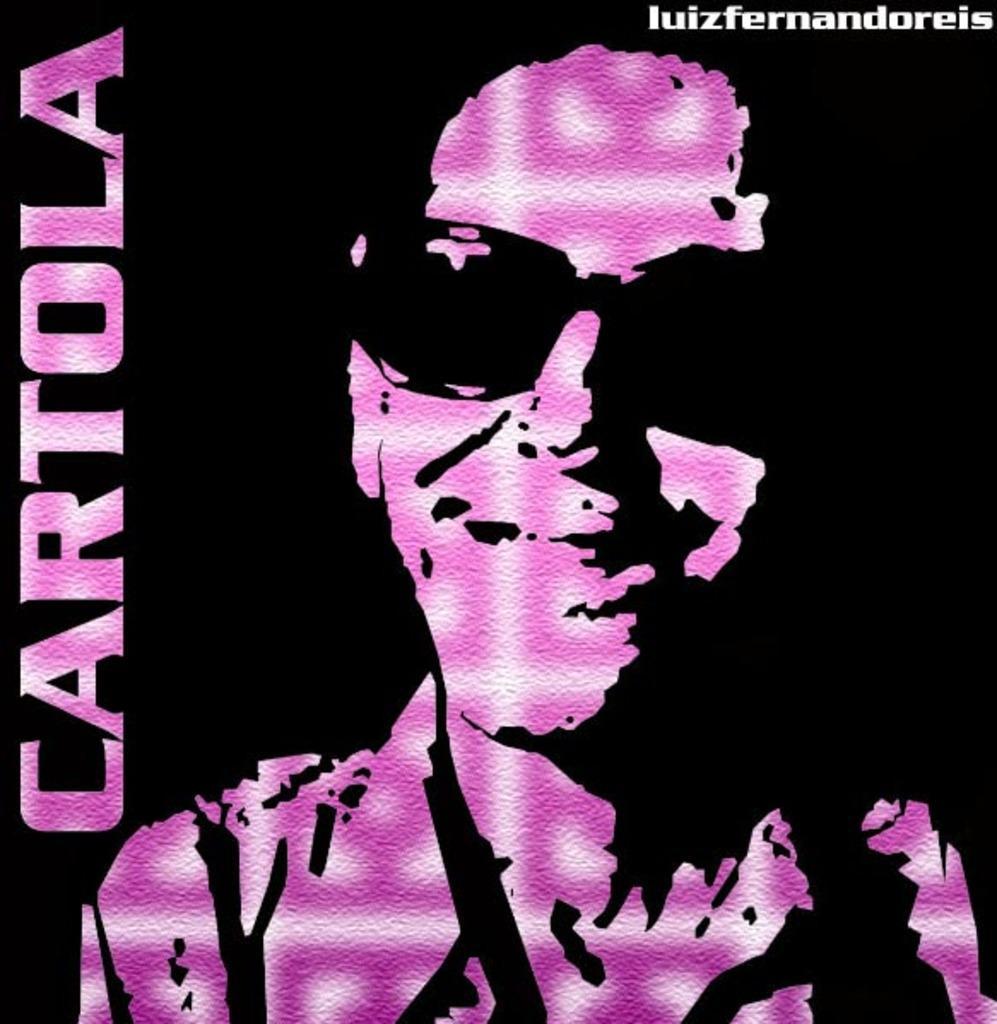Could you give a brief overview of what you see in this image? This is a poster and in this poster we can see a person wore goggle and some text. 